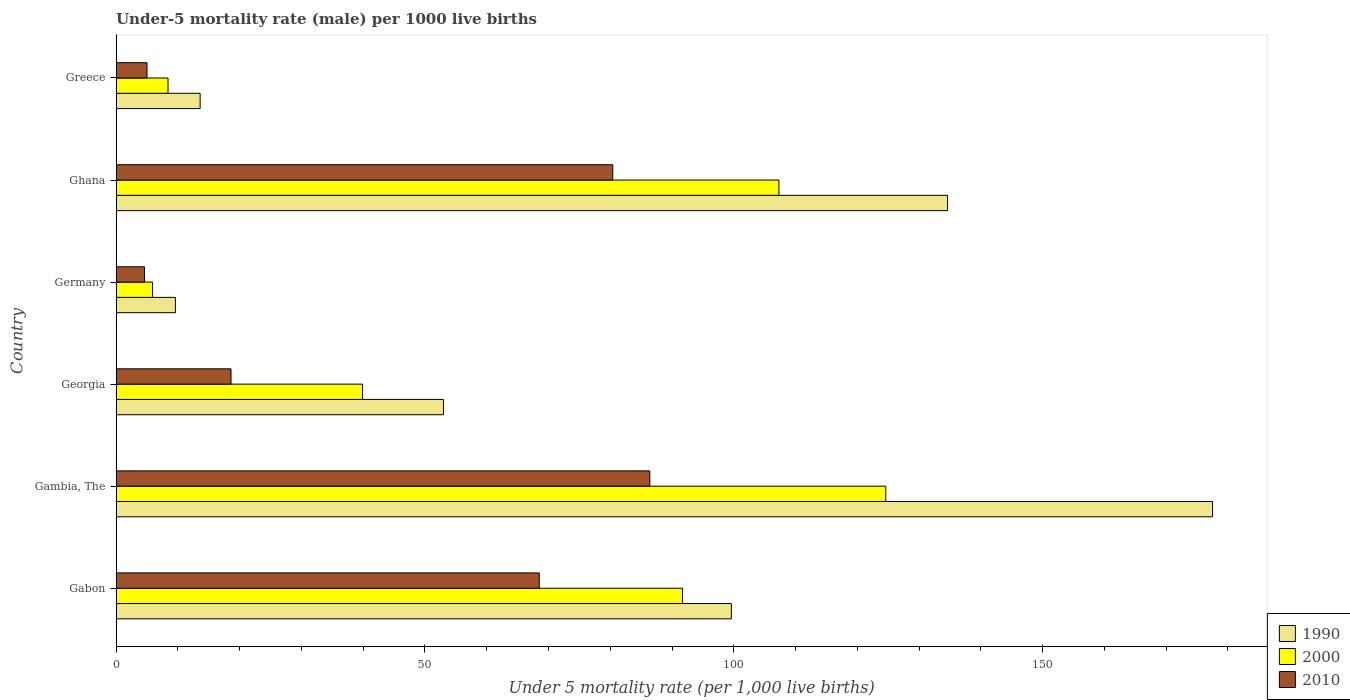Are the number of bars per tick equal to the number of legend labels?
Provide a succinct answer. Yes. How many bars are there on the 3rd tick from the top?
Keep it short and to the point. 3. What is the label of the 3rd group of bars from the top?
Your answer should be very brief. Germany. In how many cases, is the number of bars for a given country not equal to the number of legend labels?
Provide a short and direct response. 0. What is the under-five mortality rate in 1990 in Greece?
Ensure brevity in your answer.  13.6. Across all countries, what is the maximum under-five mortality rate in 2000?
Your response must be concise. 124.6. Across all countries, what is the minimum under-five mortality rate in 2010?
Provide a short and direct response. 4.6. In which country was the under-five mortality rate in 2000 maximum?
Keep it short and to the point. Gambia, The. What is the total under-five mortality rate in 1990 in the graph?
Ensure brevity in your answer.  487.9. What is the difference between the under-five mortality rate in 2000 in Gambia, The and that in Germany?
Make the answer very short. 118.7. What is the average under-five mortality rate in 1990 per country?
Give a very brief answer. 81.32. What is the ratio of the under-five mortality rate in 1990 in Gabon to that in Greece?
Provide a succinct answer. 7.32. Is the difference between the under-five mortality rate in 1990 in Germany and Greece greater than the difference between the under-five mortality rate in 2010 in Germany and Greece?
Provide a succinct answer. No. What is the difference between the highest and the second highest under-five mortality rate in 1990?
Offer a very short reply. 42.9. What is the difference between the highest and the lowest under-five mortality rate in 2010?
Your answer should be very brief. 81.8. Is the sum of the under-five mortality rate in 2000 in Gambia, The and Greece greater than the maximum under-five mortality rate in 2010 across all countries?
Your response must be concise. Yes. What does the 1st bar from the bottom in Greece represents?
Your response must be concise. 1990. How many bars are there?
Your answer should be very brief. 18. How many countries are there in the graph?
Your answer should be compact. 6. What is the difference between two consecutive major ticks on the X-axis?
Offer a very short reply. 50. Are the values on the major ticks of X-axis written in scientific E-notation?
Offer a terse response. No. Does the graph contain any zero values?
Your response must be concise. No. Does the graph contain grids?
Provide a succinct answer. No. What is the title of the graph?
Provide a succinct answer. Under-5 mortality rate (male) per 1000 live births. What is the label or title of the X-axis?
Your answer should be very brief. Under 5 mortality rate (per 1,0 live births). What is the Under 5 mortality rate (per 1,000 live births) of 1990 in Gabon?
Keep it short and to the point. 99.6. What is the Under 5 mortality rate (per 1,000 live births) of 2000 in Gabon?
Give a very brief answer. 91.7. What is the Under 5 mortality rate (per 1,000 live births) in 2010 in Gabon?
Keep it short and to the point. 68.5. What is the Under 5 mortality rate (per 1,000 live births) in 1990 in Gambia, The?
Provide a short and direct response. 177.5. What is the Under 5 mortality rate (per 1,000 live births) of 2000 in Gambia, The?
Your response must be concise. 124.6. What is the Under 5 mortality rate (per 1,000 live births) in 2010 in Gambia, The?
Ensure brevity in your answer.  86.4. What is the Under 5 mortality rate (per 1,000 live births) in 2000 in Georgia?
Provide a succinct answer. 39.9. What is the Under 5 mortality rate (per 1,000 live births) in 2000 in Germany?
Ensure brevity in your answer.  5.9. What is the Under 5 mortality rate (per 1,000 live births) of 2010 in Germany?
Make the answer very short. 4.6. What is the Under 5 mortality rate (per 1,000 live births) in 1990 in Ghana?
Give a very brief answer. 134.6. What is the Under 5 mortality rate (per 1,000 live births) in 2000 in Ghana?
Ensure brevity in your answer.  107.3. What is the Under 5 mortality rate (per 1,000 live births) in 2010 in Ghana?
Offer a terse response. 80.4. What is the Under 5 mortality rate (per 1,000 live births) in 1990 in Greece?
Provide a succinct answer. 13.6. What is the Under 5 mortality rate (per 1,000 live births) in 2000 in Greece?
Your answer should be compact. 8.4. What is the Under 5 mortality rate (per 1,000 live births) in 2010 in Greece?
Give a very brief answer. 5. Across all countries, what is the maximum Under 5 mortality rate (per 1,000 live births) of 1990?
Provide a short and direct response. 177.5. Across all countries, what is the maximum Under 5 mortality rate (per 1,000 live births) in 2000?
Offer a terse response. 124.6. Across all countries, what is the maximum Under 5 mortality rate (per 1,000 live births) of 2010?
Your response must be concise. 86.4. Across all countries, what is the minimum Under 5 mortality rate (per 1,000 live births) of 1990?
Provide a short and direct response. 9.6. Across all countries, what is the minimum Under 5 mortality rate (per 1,000 live births) of 2010?
Ensure brevity in your answer.  4.6. What is the total Under 5 mortality rate (per 1,000 live births) of 1990 in the graph?
Give a very brief answer. 487.9. What is the total Under 5 mortality rate (per 1,000 live births) of 2000 in the graph?
Ensure brevity in your answer.  377.8. What is the total Under 5 mortality rate (per 1,000 live births) in 2010 in the graph?
Your answer should be very brief. 263.5. What is the difference between the Under 5 mortality rate (per 1,000 live births) of 1990 in Gabon and that in Gambia, The?
Offer a terse response. -77.9. What is the difference between the Under 5 mortality rate (per 1,000 live births) of 2000 in Gabon and that in Gambia, The?
Make the answer very short. -32.9. What is the difference between the Under 5 mortality rate (per 1,000 live births) in 2010 in Gabon and that in Gambia, The?
Provide a succinct answer. -17.9. What is the difference between the Under 5 mortality rate (per 1,000 live births) of 1990 in Gabon and that in Georgia?
Your answer should be compact. 46.6. What is the difference between the Under 5 mortality rate (per 1,000 live births) in 2000 in Gabon and that in Georgia?
Provide a succinct answer. 51.8. What is the difference between the Under 5 mortality rate (per 1,000 live births) of 2010 in Gabon and that in Georgia?
Offer a terse response. 49.9. What is the difference between the Under 5 mortality rate (per 1,000 live births) of 2000 in Gabon and that in Germany?
Offer a terse response. 85.8. What is the difference between the Under 5 mortality rate (per 1,000 live births) in 2010 in Gabon and that in Germany?
Provide a succinct answer. 63.9. What is the difference between the Under 5 mortality rate (per 1,000 live births) in 1990 in Gabon and that in Ghana?
Your response must be concise. -35. What is the difference between the Under 5 mortality rate (per 1,000 live births) in 2000 in Gabon and that in Ghana?
Make the answer very short. -15.6. What is the difference between the Under 5 mortality rate (per 1,000 live births) of 2000 in Gabon and that in Greece?
Provide a succinct answer. 83.3. What is the difference between the Under 5 mortality rate (per 1,000 live births) in 2010 in Gabon and that in Greece?
Provide a short and direct response. 63.5. What is the difference between the Under 5 mortality rate (per 1,000 live births) of 1990 in Gambia, The and that in Georgia?
Your response must be concise. 124.5. What is the difference between the Under 5 mortality rate (per 1,000 live births) of 2000 in Gambia, The and that in Georgia?
Offer a terse response. 84.7. What is the difference between the Under 5 mortality rate (per 1,000 live births) of 2010 in Gambia, The and that in Georgia?
Offer a very short reply. 67.8. What is the difference between the Under 5 mortality rate (per 1,000 live births) of 1990 in Gambia, The and that in Germany?
Give a very brief answer. 167.9. What is the difference between the Under 5 mortality rate (per 1,000 live births) of 2000 in Gambia, The and that in Germany?
Keep it short and to the point. 118.7. What is the difference between the Under 5 mortality rate (per 1,000 live births) in 2010 in Gambia, The and that in Germany?
Ensure brevity in your answer.  81.8. What is the difference between the Under 5 mortality rate (per 1,000 live births) of 1990 in Gambia, The and that in Ghana?
Offer a terse response. 42.9. What is the difference between the Under 5 mortality rate (per 1,000 live births) of 2000 in Gambia, The and that in Ghana?
Give a very brief answer. 17.3. What is the difference between the Under 5 mortality rate (per 1,000 live births) in 2010 in Gambia, The and that in Ghana?
Ensure brevity in your answer.  6. What is the difference between the Under 5 mortality rate (per 1,000 live births) in 1990 in Gambia, The and that in Greece?
Provide a short and direct response. 163.9. What is the difference between the Under 5 mortality rate (per 1,000 live births) in 2000 in Gambia, The and that in Greece?
Offer a terse response. 116.2. What is the difference between the Under 5 mortality rate (per 1,000 live births) of 2010 in Gambia, The and that in Greece?
Make the answer very short. 81.4. What is the difference between the Under 5 mortality rate (per 1,000 live births) in 1990 in Georgia and that in Germany?
Your answer should be compact. 43.4. What is the difference between the Under 5 mortality rate (per 1,000 live births) of 2000 in Georgia and that in Germany?
Ensure brevity in your answer.  34. What is the difference between the Under 5 mortality rate (per 1,000 live births) in 1990 in Georgia and that in Ghana?
Give a very brief answer. -81.6. What is the difference between the Under 5 mortality rate (per 1,000 live births) of 2000 in Georgia and that in Ghana?
Make the answer very short. -67.4. What is the difference between the Under 5 mortality rate (per 1,000 live births) in 2010 in Georgia and that in Ghana?
Provide a short and direct response. -61.8. What is the difference between the Under 5 mortality rate (per 1,000 live births) in 1990 in Georgia and that in Greece?
Your answer should be very brief. 39.4. What is the difference between the Under 5 mortality rate (per 1,000 live births) in 2000 in Georgia and that in Greece?
Give a very brief answer. 31.5. What is the difference between the Under 5 mortality rate (per 1,000 live births) in 2010 in Georgia and that in Greece?
Make the answer very short. 13.6. What is the difference between the Under 5 mortality rate (per 1,000 live births) in 1990 in Germany and that in Ghana?
Provide a short and direct response. -125. What is the difference between the Under 5 mortality rate (per 1,000 live births) of 2000 in Germany and that in Ghana?
Offer a terse response. -101.4. What is the difference between the Under 5 mortality rate (per 1,000 live births) in 2010 in Germany and that in Ghana?
Give a very brief answer. -75.8. What is the difference between the Under 5 mortality rate (per 1,000 live births) of 1990 in Ghana and that in Greece?
Give a very brief answer. 121. What is the difference between the Under 5 mortality rate (per 1,000 live births) in 2000 in Ghana and that in Greece?
Offer a terse response. 98.9. What is the difference between the Under 5 mortality rate (per 1,000 live births) of 2010 in Ghana and that in Greece?
Your response must be concise. 75.4. What is the difference between the Under 5 mortality rate (per 1,000 live births) in 1990 in Gabon and the Under 5 mortality rate (per 1,000 live births) in 2000 in Georgia?
Provide a short and direct response. 59.7. What is the difference between the Under 5 mortality rate (per 1,000 live births) in 2000 in Gabon and the Under 5 mortality rate (per 1,000 live births) in 2010 in Georgia?
Keep it short and to the point. 73.1. What is the difference between the Under 5 mortality rate (per 1,000 live births) of 1990 in Gabon and the Under 5 mortality rate (per 1,000 live births) of 2000 in Germany?
Your answer should be compact. 93.7. What is the difference between the Under 5 mortality rate (per 1,000 live births) in 1990 in Gabon and the Under 5 mortality rate (per 1,000 live births) in 2010 in Germany?
Your answer should be compact. 95. What is the difference between the Under 5 mortality rate (per 1,000 live births) in 2000 in Gabon and the Under 5 mortality rate (per 1,000 live births) in 2010 in Germany?
Ensure brevity in your answer.  87.1. What is the difference between the Under 5 mortality rate (per 1,000 live births) in 1990 in Gabon and the Under 5 mortality rate (per 1,000 live births) in 2000 in Greece?
Your response must be concise. 91.2. What is the difference between the Under 5 mortality rate (per 1,000 live births) in 1990 in Gabon and the Under 5 mortality rate (per 1,000 live births) in 2010 in Greece?
Make the answer very short. 94.6. What is the difference between the Under 5 mortality rate (per 1,000 live births) of 2000 in Gabon and the Under 5 mortality rate (per 1,000 live births) of 2010 in Greece?
Offer a very short reply. 86.7. What is the difference between the Under 5 mortality rate (per 1,000 live births) in 1990 in Gambia, The and the Under 5 mortality rate (per 1,000 live births) in 2000 in Georgia?
Make the answer very short. 137.6. What is the difference between the Under 5 mortality rate (per 1,000 live births) of 1990 in Gambia, The and the Under 5 mortality rate (per 1,000 live births) of 2010 in Georgia?
Ensure brevity in your answer.  158.9. What is the difference between the Under 5 mortality rate (per 1,000 live births) of 2000 in Gambia, The and the Under 5 mortality rate (per 1,000 live births) of 2010 in Georgia?
Give a very brief answer. 106. What is the difference between the Under 5 mortality rate (per 1,000 live births) of 1990 in Gambia, The and the Under 5 mortality rate (per 1,000 live births) of 2000 in Germany?
Offer a very short reply. 171.6. What is the difference between the Under 5 mortality rate (per 1,000 live births) of 1990 in Gambia, The and the Under 5 mortality rate (per 1,000 live births) of 2010 in Germany?
Your response must be concise. 172.9. What is the difference between the Under 5 mortality rate (per 1,000 live births) in 2000 in Gambia, The and the Under 5 mortality rate (per 1,000 live births) in 2010 in Germany?
Make the answer very short. 120. What is the difference between the Under 5 mortality rate (per 1,000 live births) of 1990 in Gambia, The and the Under 5 mortality rate (per 1,000 live births) of 2000 in Ghana?
Give a very brief answer. 70.2. What is the difference between the Under 5 mortality rate (per 1,000 live births) of 1990 in Gambia, The and the Under 5 mortality rate (per 1,000 live births) of 2010 in Ghana?
Provide a succinct answer. 97.1. What is the difference between the Under 5 mortality rate (per 1,000 live births) in 2000 in Gambia, The and the Under 5 mortality rate (per 1,000 live births) in 2010 in Ghana?
Your response must be concise. 44.2. What is the difference between the Under 5 mortality rate (per 1,000 live births) of 1990 in Gambia, The and the Under 5 mortality rate (per 1,000 live births) of 2000 in Greece?
Make the answer very short. 169.1. What is the difference between the Under 5 mortality rate (per 1,000 live births) in 1990 in Gambia, The and the Under 5 mortality rate (per 1,000 live births) in 2010 in Greece?
Your response must be concise. 172.5. What is the difference between the Under 5 mortality rate (per 1,000 live births) in 2000 in Gambia, The and the Under 5 mortality rate (per 1,000 live births) in 2010 in Greece?
Your answer should be compact. 119.6. What is the difference between the Under 5 mortality rate (per 1,000 live births) of 1990 in Georgia and the Under 5 mortality rate (per 1,000 live births) of 2000 in Germany?
Offer a very short reply. 47.1. What is the difference between the Under 5 mortality rate (per 1,000 live births) in 1990 in Georgia and the Under 5 mortality rate (per 1,000 live births) in 2010 in Germany?
Offer a very short reply. 48.4. What is the difference between the Under 5 mortality rate (per 1,000 live births) in 2000 in Georgia and the Under 5 mortality rate (per 1,000 live births) in 2010 in Germany?
Your answer should be compact. 35.3. What is the difference between the Under 5 mortality rate (per 1,000 live births) in 1990 in Georgia and the Under 5 mortality rate (per 1,000 live births) in 2000 in Ghana?
Make the answer very short. -54.3. What is the difference between the Under 5 mortality rate (per 1,000 live births) in 1990 in Georgia and the Under 5 mortality rate (per 1,000 live births) in 2010 in Ghana?
Ensure brevity in your answer.  -27.4. What is the difference between the Under 5 mortality rate (per 1,000 live births) in 2000 in Georgia and the Under 5 mortality rate (per 1,000 live births) in 2010 in Ghana?
Offer a very short reply. -40.5. What is the difference between the Under 5 mortality rate (per 1,000 live births) of 1990 in Georgia and the Under 5 mortality rate (per 1,000 live births) of 2000 in Greece?
Provide a short and direct response. 44.6. What is the difference between the Under 5 mortality rate (per 1,000 live births) of 2000 in Georgia and the Under 5 mortality rate (per 1,000 live births) of 2010 in Greece?
Your answer should be very brief. 34.9. What is the difference between the Under 5 mortality rate (per 1,000 live births) of 1990 in Germany and the Under 5 mortality rate (per 1,000 live births) of 2000 in Ghana?
Ensure brevity in your answer.  -97.7. What is the difference between the Under 5 mortality rate (per 1,000 live births) of 1990 in Germany and the Under 5 mortality rate (per 1,000 live births) of 2010 in Ghana?
Make the answer very short. -70.8. What is the difference between the Under 5 mortality rate (per 1,000 live births) in 2000 in Germany and the Under 5 mortality rate (per 1,000 live births) in 2010 in Ghana?
Provide a succinct answer. -74.5. What is the difference between the Under 5 mortality rate (per 1,000 live births) of 1990 in Germany and the Under 5 mortality rate (per 1,000 live births) of 2000 in Greece?
Give a very brief answer. 1.2. What is the difference between the Under 5 mortality rate (per 1,000 live births) of 1990 in Germany and the Under 5 mortality rate (per 1,000 live births) of 2010 in Greece?
Provide a short and direct response. 4.6. What is the difference between the Under 5 mortality rate (per 1,000 live births) of 2000 in Germany and the Under 5 mortality rate (per 1,000 live births) of 2010 in Greece?
Provide a succinct answer. 0.9. What is the difference between the Under 5 mortality rate (per 1,000 live births) in 1990 in Ghana and the Under 5 mortality rate (per 1,000 live births) in 2000 in Greece?
Provide a succinct answer. 126.2. What is the difference between the Under 5 mortality rate (per 1,000 live births) in 1990 in Ghana and the Under 5 mortality rate (per 1,000 live births) in 2010 in Greece?
Make the answer very short. 129.6. What is the difference between the Under 5 mortality rate (per 1,000 live births) of 2000 in Ghana and the Under 5 mortality rate (per 1,000 live births) of 2010 in Greece?
Make the answer very short. 102.3. What is the average Under 5 mortality rate (per 1,000 live births) of 1990 per country?
Offer a terse response. 81.32. What is the average Under 5 mortality rate (per 1,000 live births) of 2000 per country?
Make the answer very short. 62.97. What is the average Under 5 mortality rate (per 1,000 live births) in 2010 per country?
Ensure brevity in your answer.  43.92. What is the difference between the Under 5 mortality rate (per 1,000 live births) of 1990 and Under 5 mortality rate (per 1,000 live births) of 2000 in Gabon?
Your answer should be compact. 7.9. What is the difference between the Under 5 mortality rate (per 1,000 live births) in 1990 and Under 5 mortality rate (per 1,000 live births) in 2010 in Gabon?
Offer a terse response. 31.1. What is the difference between the Under 5 mortality rate (per 1,000 live births) of 2000 and Under 5 mortality rate (per 1,000 live births) of 2010 in Gabon?
Make the answer very short. 23.2. What is the difference between the Under 5 mortality rate (per 1,000 live births) of 1990 and Under 5 mortality rate (per 1,000 live births) of 2000 in Gambia, The?
Provide a short and direct response. 52.9. What is the difference between the Under 5 mortality rate (per 1,000 live births) in 1990 and Under 5 mortality rate (per 1,000 live births) in 2010 in Gambia, The?
Your response must be concise. 91.1. What is the difference between the Under 5 mortality rate (per 1,000 live births) of 2000 and Under 5 mortality rate (per 1,000 live births) of 2010 in Gambia, The?
Give a very brief answer. 38.2. What is the difference between the Under 5 mortality rate (per 1,000 live births) of 1990 and Under 5 mortality rate (per 1,000 live births) of 2010 in Georgia?
Your response must be concise. 34.4. What is the difference between the Under 5 mortality rate (per 1,000 live births) in 2000 and Under 5 mortality rate (per 1,000 live births) in 2010 in Georgia?
Give a very brief answer. 21.3. What is the difference between the Under 5 mortality rate (per 1,000 live births) of 1990 and Under 5 mortality rate (per 1,000 live births) of 2010 in Germany?
Provide a short and direct response. 5. What is the difference between the Under 5 mortality rate (per 1,000 live births) of 1990 and Under 5 mortality rate (per 1,000 live births) of 2000 in Ghana?
Your answer should be very brief. 27.3. What is the difference between the Under 5 mortality rate (per 1,000 live births) of 1990 and Under 5 mortality rate (per 1,000 live births) of 2010 in Ghana?
Offer a terse response. 54.2. What is the difference between the Under 5 mortality rate (per 1,000 live births) of 2000 and Under 5 mortality rate (per 1,000 live births) of 2010 in Ghana?
Your response must be concise. 26.9. What is the difference between the Under 5 mortality rate (per 1,000 live births) of 1990 and Under 5 mortality rate (per 1,000 live births) of 2000 in Greece?
Your response must be concise. 5.2. What is the difference between the Under 5 mortality rate (per 1,000 live births) in 1990 and Under 5 mortality rate (per 1,000 live births) in 2010 in Greece?
Ensure brevity in your answer.  8.6. What is the ratio of the Under 5 mortality rate (per 1,000 live births) in 1990 in Gabon to that in Gambia, The?
Give a very brief answer. 0.56. What is the ratio of the Under 5 mortality rate (per 1,000 live births) in 2000 in Gabon to that in Gambia, The?
Offer a terse response. 0.74. What is the ratio of the Under 5 mortality rate (per 1,000 live births) of 2010 in Gabon to that in Gambia, The?
Ensure brevity in your answer.  0.79. What is the ratio of the Under 5 mortality rate (per 1,000 live births) of 1990 in Gabon to that in Georgia?
Keep it short and to the point. 1.88. What is the ratio of the Under 5 mortality rate (per 1,000 live births) of 2000 in Gabon to that in Georgia?
Provide a short and direct response. 2.3. What is the ratio of the Under 5 mortality rate (per 1,000 live births) in 2010 in Gabon to that in Georgia?
Provide a short and direct response. 3.68. What is the ratio of the Under 5 mortality rate (per 1,000 live births) of 1990 in Gabon to that in Germany?
Offer a very short reply. 10.38. What is the ratio of the Under 5 mortality rate (per 1,000 live births) in 2000 in Gabon to that in Germany?
Keep it short and to the point. 15.54. What is the ratio of the Under 5 mortality rate (per 1,000 live births) of 2010 in Gabon to that in Germany?
Offer a very short reply. 14.89. What is the ratio of the Under 5 mortality rate (per 1,000 live births) of 1990 in Gabon to that in Ghana?
Provide a short and direct response. 0.74. What is the ratio of the Under 5 mortality rate (per 1,000 live births) in 2000 in Gabon to that in Ghana?
Ensure brevity in your answer.  0.85. What is the ratio of the Under 5 mortality rate (per 1,000 live births) in 2010 in Gabon to that in Ghana?
Provide a succinct answer. 0.85. What is the ratio of the Under 5 mortality rate (per 1,000 live births) of 1990 in Gabon to that in Greece?
Keep it short and to the point. 7.32. What is the ratio of the Under 5 mortality rate (per 1,000 live births) of 2000 in Gabon to that in Greece?
Keep it short and to the point. 10.92. What is the ratio of the Under 5 mortality rate (per 1,000 live births) in 1990 in Gambia, The to that in Georgia?
Provide a short and direct response. 3.35. What is the ratio of the Under 5 mortality rate (per 1,000 live births) in 2000 in Gambia, The to that in Georgia?
Give a very brief answer. 3.12. What is the ratio of the Under 5 mortality rate (per 1,000 live births) in 2010 in Gambia, The to that in Georgia?
Your answer should be very brief. 4.65. What is the ratio of the Under 5 mortality rate (per 1,000 live births) of 1990 in Gambia, The to that in Germany?
Give a very brief answer. 18.49. What is the ratio of the Under 5 mortality rate (per 1,000 live births) of 2000 in Gambia, The to that in Germany?
Give a very brief answer. 21.12. What is the ratio of the Under 5 mortality rate (per 1,000 live births) of 2010 in Gambia, The to that in Germany?
Give a very brief answer. 18.78. What is the ratio of the Under 5 mortality rate (per 1,000 live births) in 1990 in Gambia, The to that in Ghana?
Your response must be concise. 1.32. What is the ratio of the Under 5 mortality rate (per 1,000 live births) in 2000 in Gambia, The to that in Ghana?
Make the answer very short. 1.16. What is the ratio of the Under 5 mortality rate (per 1,000 live births) of 2010 in Gambia, The to that in Ghana?
Your answer should be compact. 1.07. What is the ratio of the Under 5 mortality rate (per 1,000 live births) of 1990 in Gambia, The to that in Greece?
Provide a short and direct response. 13.05. What is the ratio of the Under 5 mortality rate (per 1,000 live births) of 2000 in Gambia, The to that in Greece?
Keep it short and to the point. 14.83. What is the ratio of the Under 5 mortality rate (per 1,000 live births) of 2010 in Gambia, The to that in Greece?
Offer a very short reply. 17.28. What is the ratio of the Under 5 mortality rate (per 1,000 live births) of 1990 in Georgia to that in Germany?
Your answer should be compact. 5.52. What is the ratio of the Under 5 mortality rate (per 1,000 live births) in 2000 in Georgia to that in Germany?
Provide a succinct answer. 6.76. What is the ratio of the Under 5 mortality rate (per 1,000 live births) of 2010 in Georgia to that in Germany?
Offer a terse response. 4.04. What is the ratio of the Under 5 mortality rate (per 1,000 live births) in 1990 in Georgia to that in Ghana?
Offer a terse response. 0.39. What is the ratio of the Under 5 mortality rate (per 1,000 live births) of 2000 in Georgia to that in Ghana?
Give a very brief answer. 0.37. What is the ratio of the Under 5 mortality rate (per 1,000 live births) in 2010 in Georgia to that in Ghana?
Your answer should be compact. 0.23. What is the ratio of the Under 5 mortality rate (per 1,000 live births) of 1990 in Georgia to that in Greece?
Make the answer very short. 3.9. What is the ratio of the Under 5 mortality rate (per 1,000 live births) in 2000 in Georgia to that in Greece?
Keep it short and to the point. 4.75. What is the ratio of the Under 5 mortality rate (per 1,000 live births) of 2010 in Georgia to that in Greece?
Your answer should be compact. 3.72. What is the ratio of the Under 5 mortality rate (per 1,000 live births) in 1990 in Germany to that in Ghana?
Your response must be concise. 0.07. What is the ratio of the Under 5 mortality rate (per 1,000 live births) in 2000 in Germany to that in Ghana?
Keep it short and to the point. 0.06. What is the ratio of the Under 5 mortality rate (per 1,000 live births) of 2010 in Germany to that in Ghana?
Give a very brief answer. 0.06. What is the ratio of the Under 5 mortality rate (per 1,000 live births) of 1990 in Germany to that in Greece?
Give a very brief answer. 0.71. What is the ratio of the Under 5 mortality rate (per 1,000 live births) of 2000 in Germany to that in Greece?
Your answer should be compact. 0.7. What is the ratio of the Under 5 mortality rate (per 1,000 live births) in 1990 in Ghana to that in Greece?
Your response must be concise. 9.9. What is the ratio of the Under 5 mortality rate (per 1,000 live births) of 2000 in Ghana to that in Greece?
Offer a very short reply. 12.77. What is the ratio of the Under 5 mortality rate (per 1,000 live births) of 2010 in Ghana to that in Greece?
Make the answer very short. 16.08. What is the difference between the highest and the second highest Under 5 mortality rate (per 1,000 live births) in 1990?
Provide a succinct answer. 42.9. What is the difference between the highest and the second highest Under 5 mortality rate (per 1,000 live births) in 2010?
Make the answer very short. 6. What is the difference between the highest and the lowest Under 5 mortality rate (per 1,000 live births) in 1990?
Ensure brevity in your answer.  167.9. What is the difference between the highest and the lowest Under 5 mortality rate (per 1,000 live births) of 2000?
Provide a short and direct response. 118.7. What is the difference between the highest and the lowest Under 5 mortality rate (per 1,000 live births) of 2010?
Keep it short and to the point. 81.8. 